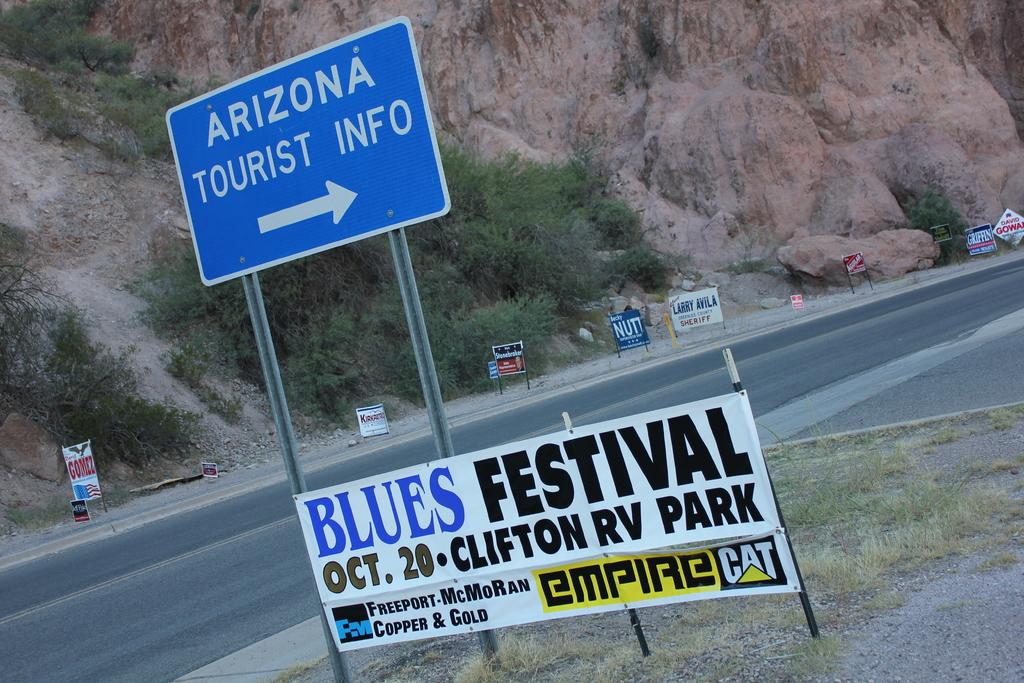<image>
Create a compact narrative representing the image presented. The street sign indicates that Arizona tourist information is to the right. 